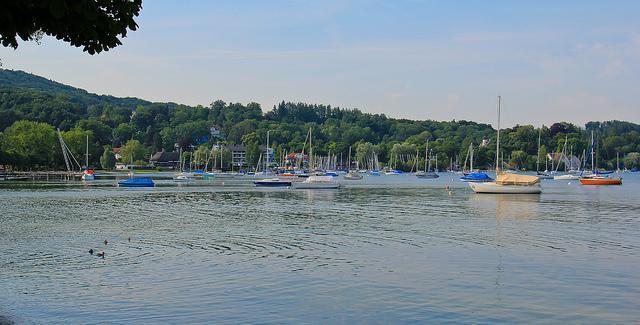How many rowboats are visible?
Give a very brief answer. 0. How many birds are flying?
Give a very brief answer. 0. 